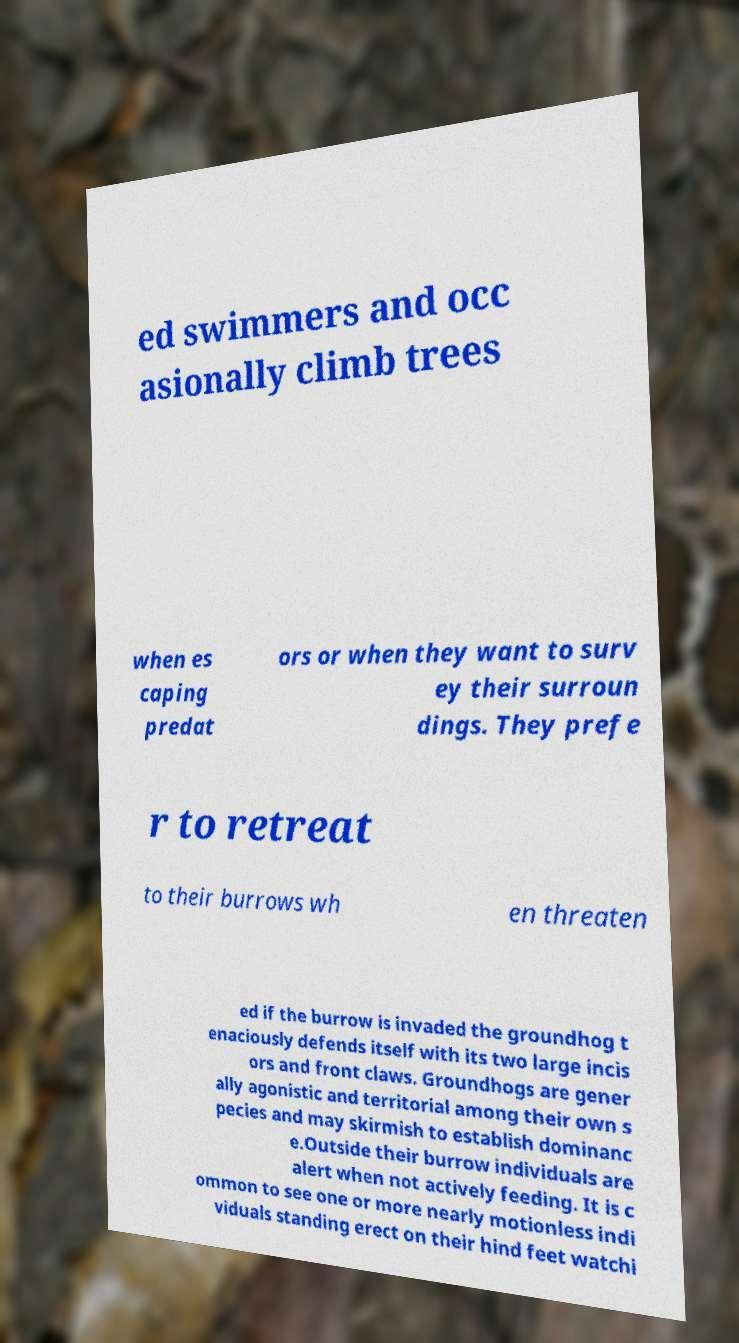Could you extract and type out the text from this image? ed swimmers and occ asionally climb trees when es caping predat ors or when they want to surv ey their surroun dings. They prefe r to retreat to their burrows wh en threaten ed if the burrow is invaded the groundhog t enaciously defends itself with its two large incis ors and front claws. Groundhogs are gener ally agonistic and territorial among their own s pecies and may skirmish to establish dominanc e.Outside their burrow individuals are alert when not actively feeding. It is c ommon to see one or more nearly motionless indi viduals standing erect on their hind feet watchi 